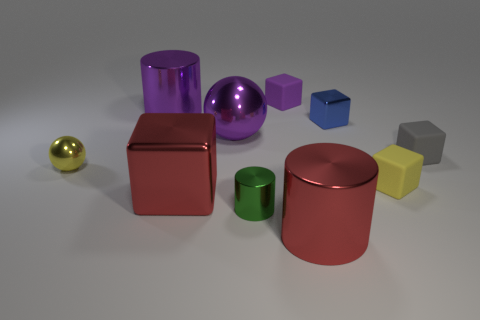Subtract all small gray rubber blocks. How many blocks are left? 4 Subtract all gray cubes. How many cubes are left? 4 Subtract all cylinders. How many objects are left? 7 Subtract 4 blocks. How many blocks are left? 1 Subtract all purple blocks. How many cyan spheres are left? 0 Subtract all cubes. Subtract all big purple rubber things. How many objects are left? 5 Add 4 tiny spheres. How many tiny spheres are left? 5 Add 7 purple balls. How many purple balls exist? 8 Subtract 1 yellow cubes. How many objects are left? 9 Subtract all gray cubes. Subtract all gray cylinders. How many cubes are left? 4 